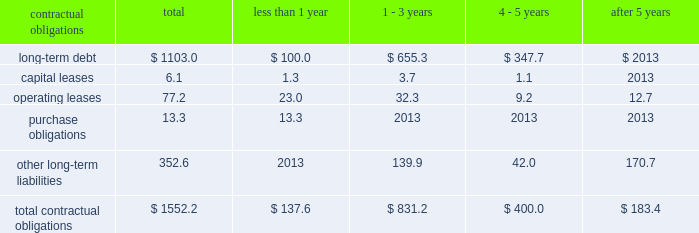Z i m m e r h o l d i n g s , i n c .
A n d s u b s i d i a r i e s 2 0 0 3 f o r m 1 0 - k contractual obligations the company has entered into contracts with various third parties in the normal course of business which will require future payments .
The table illustrates the company 2019s contractual obligations : than 1 - 3 4 - 5 after contractual obligations total 1 year years years 5 years .
Critical accounting estimates the financial results of the company are affected by the income taxes 2013 the company estimates income selection and application of accounting policies and methods .
Tax expense and income tax liabilities and assets by taxable significant accounting policies which require management 2019s jurisdiction .
Realization of deferred tax assets in each taxable judgment are discussed below .
Jurisdiction is dependent on the company 2019s ability to generate future taxable income sufficient to realize the excess inventory and instruments 2013 the company benefits .
The company evaluates deferred tax assets on must determine as of each balance sheet date how much , if an ongoing basis and provides valuation allowances if it is any , of its inventory may ultimately prove to be unsaleable or determined to be 2018 2018more likely than not 2019 2019 that the deferred unsaleable at its carrying cost .
Similarly , the company must tax benefit will not be realized .
Federal income taxes are also determine if instruments on hand will be put to provided on the portion of the income of foreign subsidiaries productive use or remain undeployed as a result of excess that is expected to be remitted to the u.s .
The company supply .
Reserves are established to effectively adjust operates within numerous taxing jurisdictions .
The company inventory and instruments to net realizable value .
To is subject to regulatory review or audit in virtually all of determine the appropriate level of reserves , the company those jurisdictions and those reviews and audits may require evaluates current stock levels in relation to historical and extended periods of time to resolve .
The company makes use expected patterns of demand for all of its products and of all available information and makes reasoned judgments instrument systems and components .
The basis for the regarding matters requiring interpretation in establishing determination is generally the same for all inventory and tax expense , liabilities and reserves .
The company believes instrument items and categories except for work-in-progress adequate provisions exist for income taxes for all periods inventory , which is recorded at cost .
Obsolete or and jurisdictions subject to review or audit .
Discontinued items are generally destroyed and completely written off .
Management evaluates the need for changes to commitments and contingencies 2013 accruals for valuation reserves based on market conditions , competitive product liability and other claims are established with offerings and other factors on a regular basis .
Centerpulse internal and external counsel based on current information historically applied a similar conceptual framework in and historical settlement information for claims , related fees estimating market value of excess inventory and instruments and for claims incurred but not reported .
An actuarial model under international financial reporting standards and is used by the company to assist management in determining u.s .
Generally accepted accounting principles .
Within that an appropriate level of accruals for product liability claims .
Framework , zimmer and centerpulse differed however , in historical patterns of claim loss development over time are certain respects , to their approaches to such estimation .
Statistically analyzed to arrive at factors which are then following the acquisition , the company determined that a applied to loss estimates in the actuarial model .
The amounts consistent approach is necessary to maintaining effective established represent management 2019s best estimate of the control over financial reporting .
Consideration was given to ultimate costs that it will incur under the various both approaches and the company established a common contingencies .
Estimation technique taking both prior approaches into account .
This change in estimate resulted in a charge to earnings of $ 3.0 million after tax in the fourth quarter .
Such change is not considered material to the company 2019s financial position , results of operations or cash flows. .
What percent of contractual obligations is long term debt? 
Computations: (1103.0 / 1552.2)
Answer: 0.7106. 